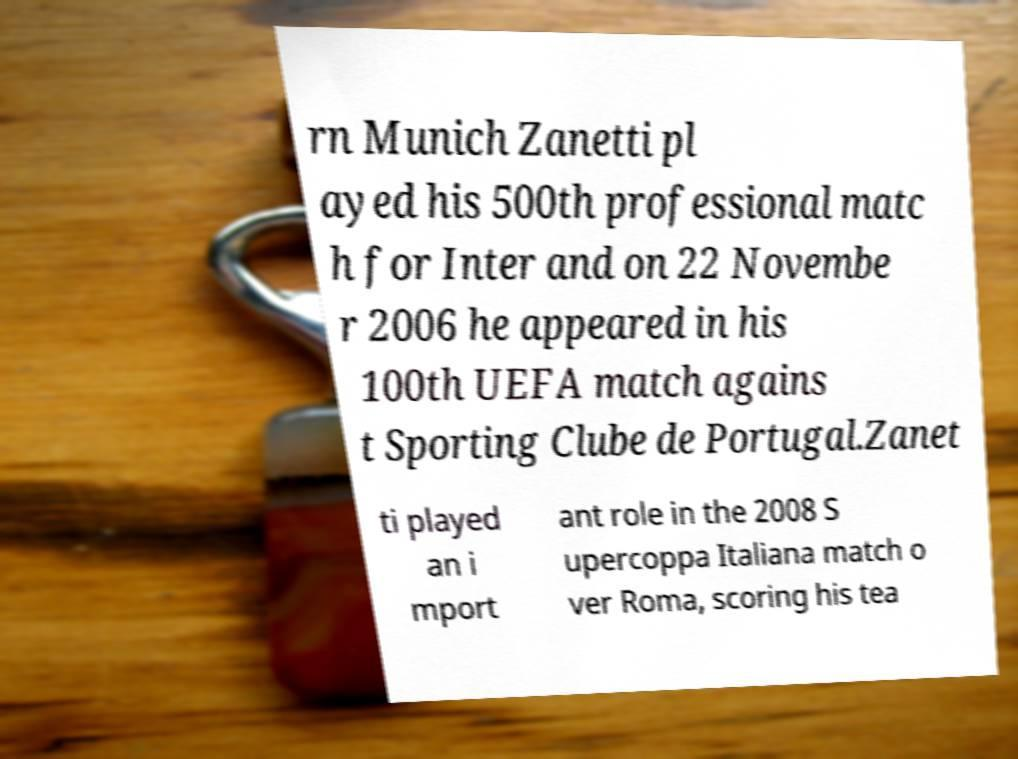What messages or text are displayed in this image? I need them in a readable, typed format. rn Munich Zanetti pl ayed his 500th professional matc h for Inter and on 22 Novembe r 2006 he appeared in his 100th UEFA match agains t Sporting Clube de Portugal.Zanet ti played an i mport ant role in the 2008 S upercoppa Italiana match o ver Roma, scoring his tea 